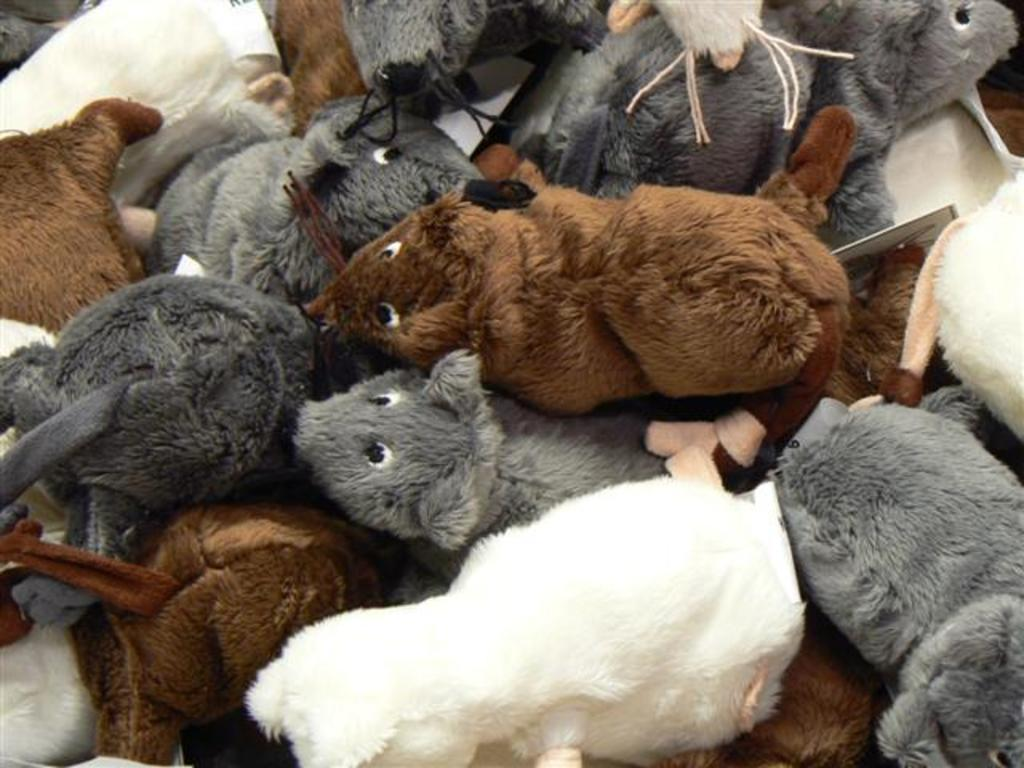What type of objects are present in the image? There are soft toys in the image. Can you describe the colors of the soft toys? The soft toys are of grey, brown, and white colors. Can you see any kitten playing with the soft toys in the image? There is no kitten present in the image. What type of vein is visible in the image? There are no veins visible in the image, as it features soft toys of different colors. 